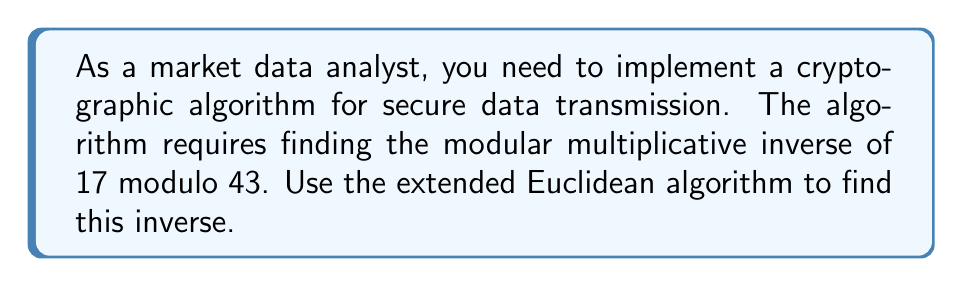Solve this math problem. Let's apply the extended Euclidean algorithm to find the modular multiplicative inverse of 17 modulo 43.

1) First, set up the initial values:
   $a = 43$, $b = 17$
   $x_1 = 1$, $y_1 = 0$
   $x_2 = 0$, $y_2 = 1$

2) Perform the division algorithm:
   $43 = 2 \times 17 + 9$
   $17 = 1 \times 9 + 8$
   $9 = 1 \times 8 + 1$
   $8 = 8 \times 1 + 0$

3) Now, work backwards to find the coefficients:
   $1 = 9 - 1 \times 8$
   $1 = 9 - 1 \times (17 - 1 \times 9) = 2 \times 9 - 1 \times 17$
   $1 = 2 \times (43 - 2 \times 17) - 1 \times 17 = 2 \times 43 - 5 \times 17$

4) Therefore, $2 \times 43 - 5 \times 17 = 1$

5) Rearranging: $-5 \times 17 \equiv 1 \pmod{43}$

6) The negative modular inverse is -5, but we need a positive number between 0 and 42.
   To get this, we add 43 to -5 until we get a positive number in this range:
   $-5 + 43 = 38$

Therefore, $38 \times 17 \equiv 1 \pmod{43}$, so 38 is the modular multiplicative inverse of 17 modulo 43.
Answer: 38 